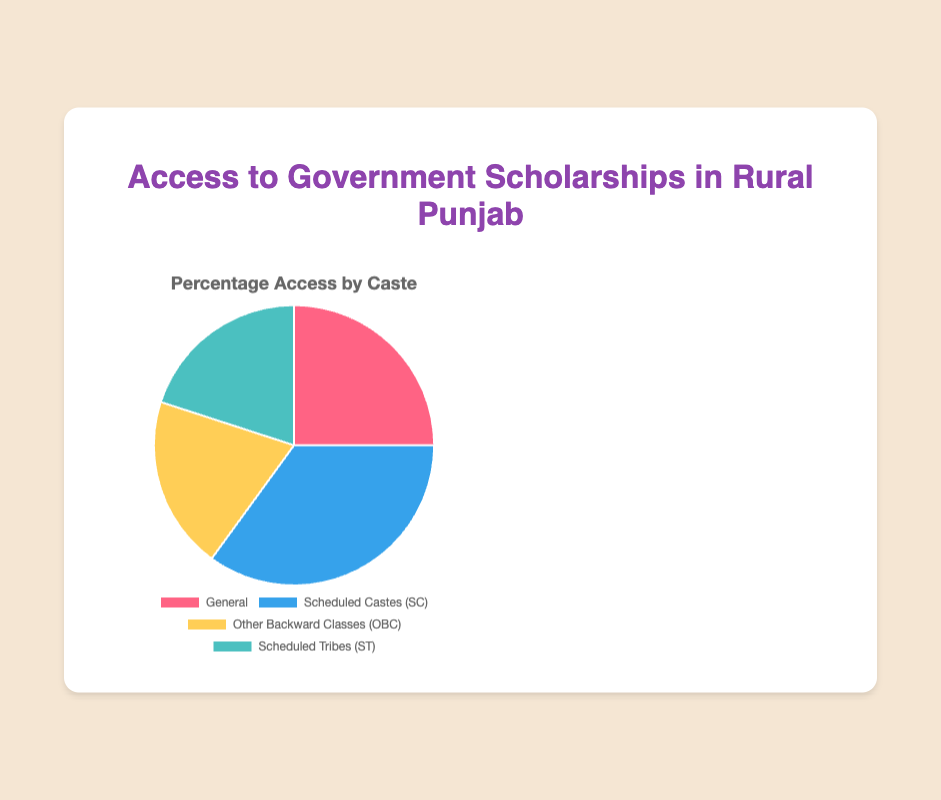What percentage of students from Scheduled Castes (SC) have access to government scholarships? According to the pie chart, the percentage of students from Scheduled Castes (SC) with access to government scholarships is clearly marked.
Answer: 35% Which caste has the lowest access to government scholarships? By looking at the pie chart and comparing the percentages, the Other Backward Classes (OBC) and Scheduled Tribes (ST) both have the lowest access at 20%.
Answer: Other Backward Classes (OBC) and Scheduled Tribes (ST) What is the combined percentage of General and OBC categories' access to government scholarships? The General category has 25% access and the OBC category has 20% access. Adding these together gives 25% + 20% = 45%.
Answer: 45% Is the percentage access of SC students higher than that of General category students? The percentage of SC students' access is 35%, which is higher than the General category's access at 25%.
Answer: Yes How much higher is the access percentage of SC students compared to OBC students? The access percentage for SC students is 35%, while for OBC students it is 20%. The difference is 35% - 20% = 15%.
Answer: 15% Which categories have an equal percentage of access to government scholarships? Observing the pie chart, both OBC and Scheduled Tribes (ST) categories have an equal percentage of 20%.
Answer: OBC and Scheduled Tribes (ST) What is the average percentage access to government scholarships across all castes? Sum the percentages (25% + 35% + 20% + 20%) = 100%, then divide by the number of categories (4) to get the average. 100% / 4 = 25%.
Answer: 25% How does the percentage access to scholarships for Scheduled Tribes (ST) compare to the overall average? The overall average percentage access is 25%. The ST category has 20% access, which is 5% lower than the average.
Answer: 5% lower What is the sum of the access percentages for SC and ST categories? The percentage for SC is 35% and for ST is 20%. Adding these gives 35% + 20% = 55%.
Answer: 55% Which category has a higher percentage access to scholarships: OBC or General? The General category has 25% access, while the OBC category has 20% access. General category has a higher percentage.
Answer: General 